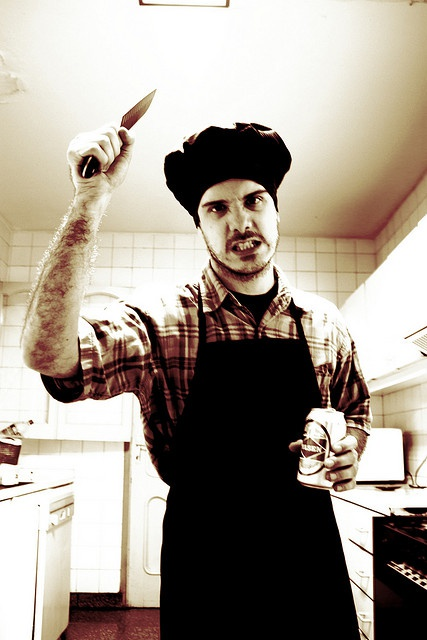Describe the objects in this image and their specific colors. I can see people in beige, black, ivory, maroon, and tan tones, oven in beige, black, and maroon tones, oven in beige, ivory, and tan tones, bottle in beige, white, maroon, and black tones, and microwave in beige, white, black, and tan tones in this image. 